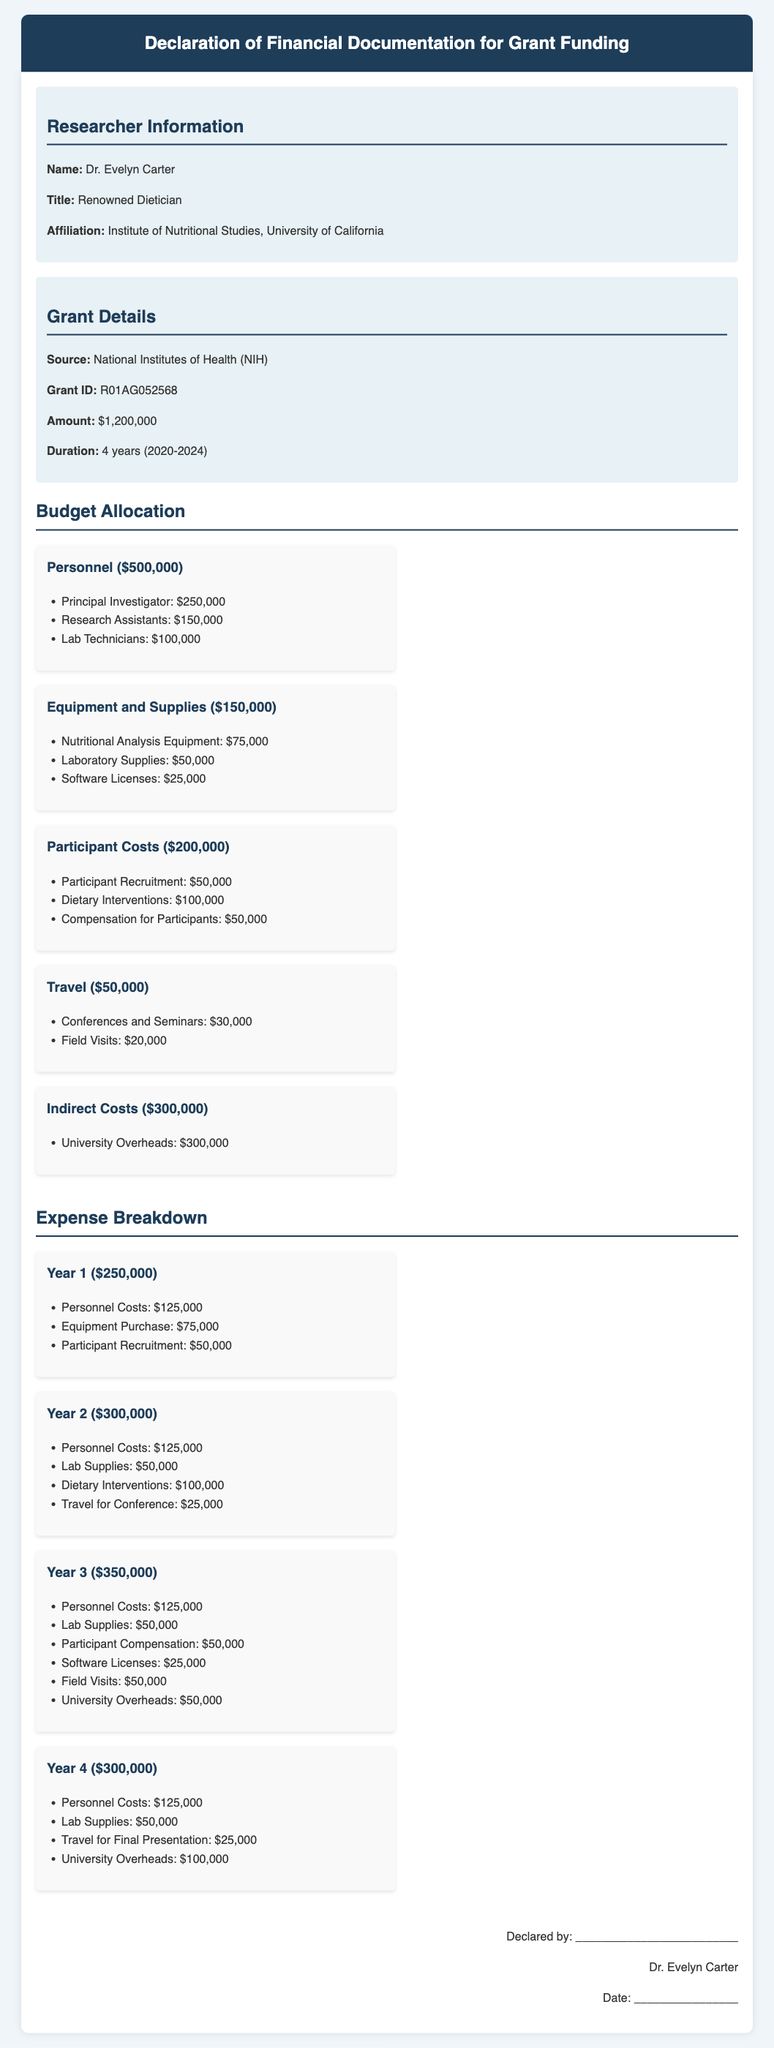What is the name of the principal investigator? The name of the principal investigator is provided in the researcher information section of the document.
Answer: Dr. Evelyn Carter What is the total grant amount received? The total grant amount is mentioned in the grant details section of the document.
Answer: $1,200,000 How many years is the grant duration? The duration of the grant is indicated in the grant details section of the document.
Answer: 4 years What is the budget allocation for personnel? The budget allocation for personnel is found in the budget section, detailing specific allocations.
Answer: $500,000 How much is allocated for participant recruitment? The allocation for participant recruitment is specified under participant costs in the budget section.
Answer: $50,000 What are the total expenses for Year 2? Total expenses for each year are listed separately under the expense breakdown section.
Answer: $300,000 What is the cost of nutritional analysis equipment? The cost for nutritional analysis equipment is listed under equipment and supplies.
Answer: $75,000 Which agency provided the grant? The agency that provided the grant is mentioned in the grant details section.
Answer: National Institutes of Health (NIH) What is the budget for indirect costs? Indirect costs are specified in the budget allocation section of the document.
Answer: $300,000 